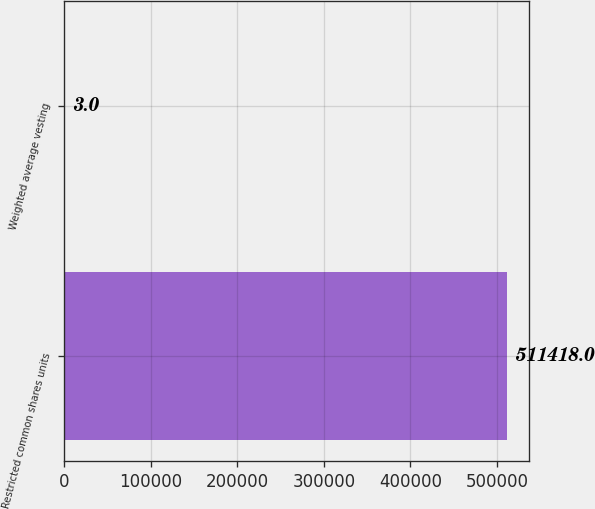<chart> <loc_0><loc_0><loc_500><loc_500><bar_chart><fcel>Restricted common shares units<fcel>Weighted average vesting<nl><fcel>511418<fcel>3<nl></chart> 